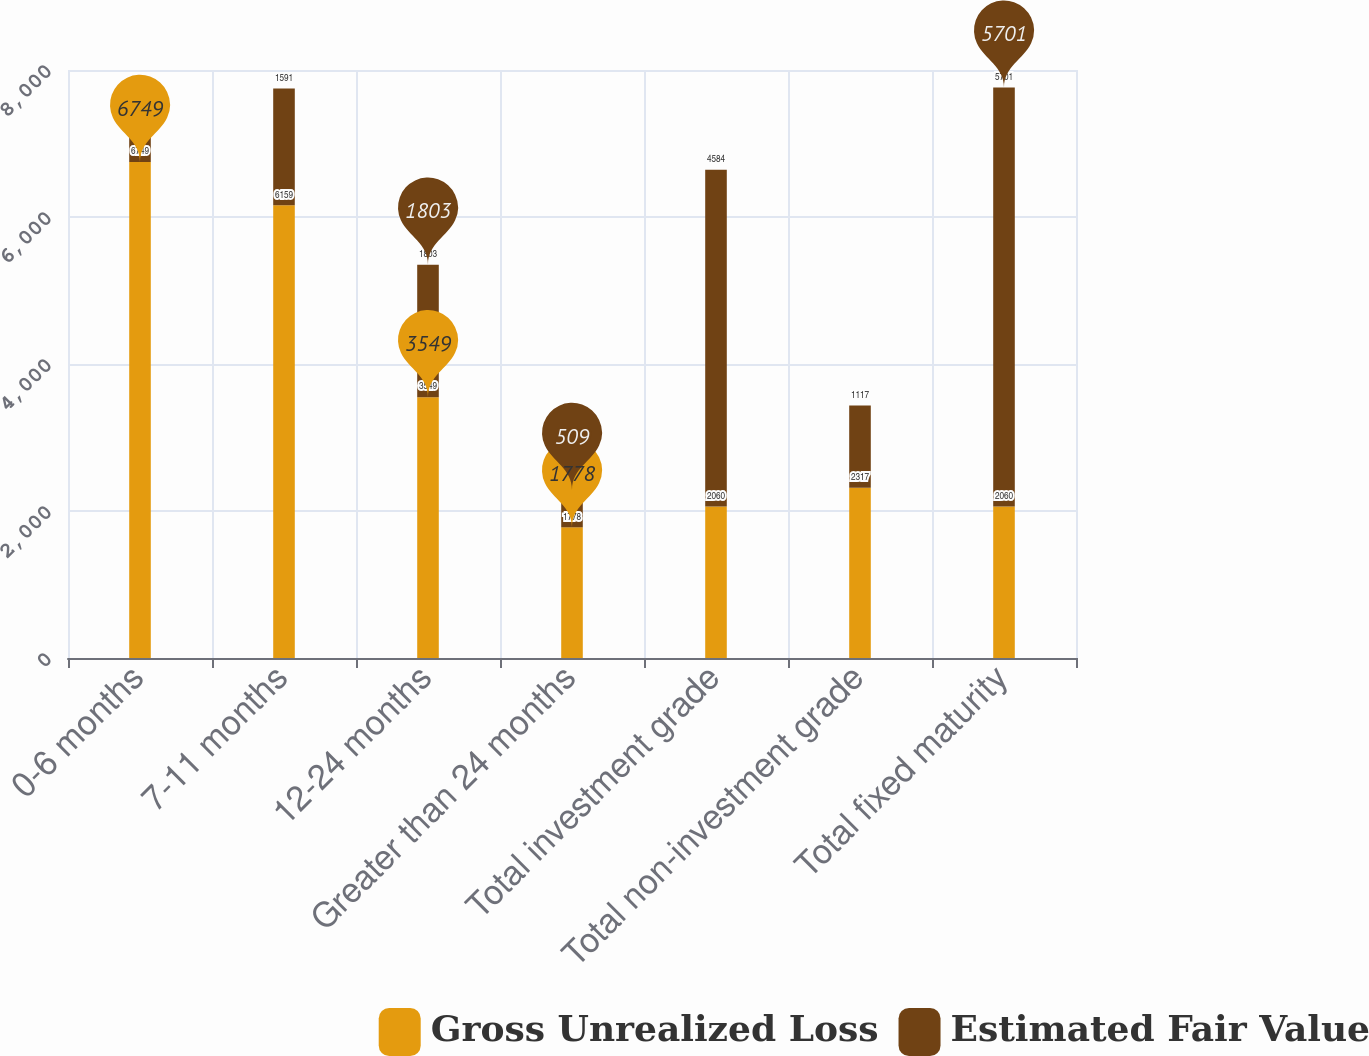Convert chart to OTSL. <chart><loc_0><loc_0><loc_500><loc_500><stacked_bar_chart><ecel><fcel>0-6 months<fcel>7-11 months<fcel>12-24 months<fcel>Greater than 24 months<fcel>Total investment grade<fcel>Total non-investment grade<fcel>Total fixed maturity<nl><fcel>Gross Unrealized Loss<fcel>6749<fcel>6159<fcel>3549<fcel>1778<fcel>2060<fcel>2317<fcel>2060<nl><fcel>Estimated Fair Value<fcel>681<fcel>1591<fcel>1803<fcel>509<fcel>4584<fcel>1117<fcel>5701<nl></chart> 